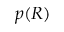Convert formula to latex. <formula><loc_0><loc_0><loc_500><loc_500>p ( R )</formula> 